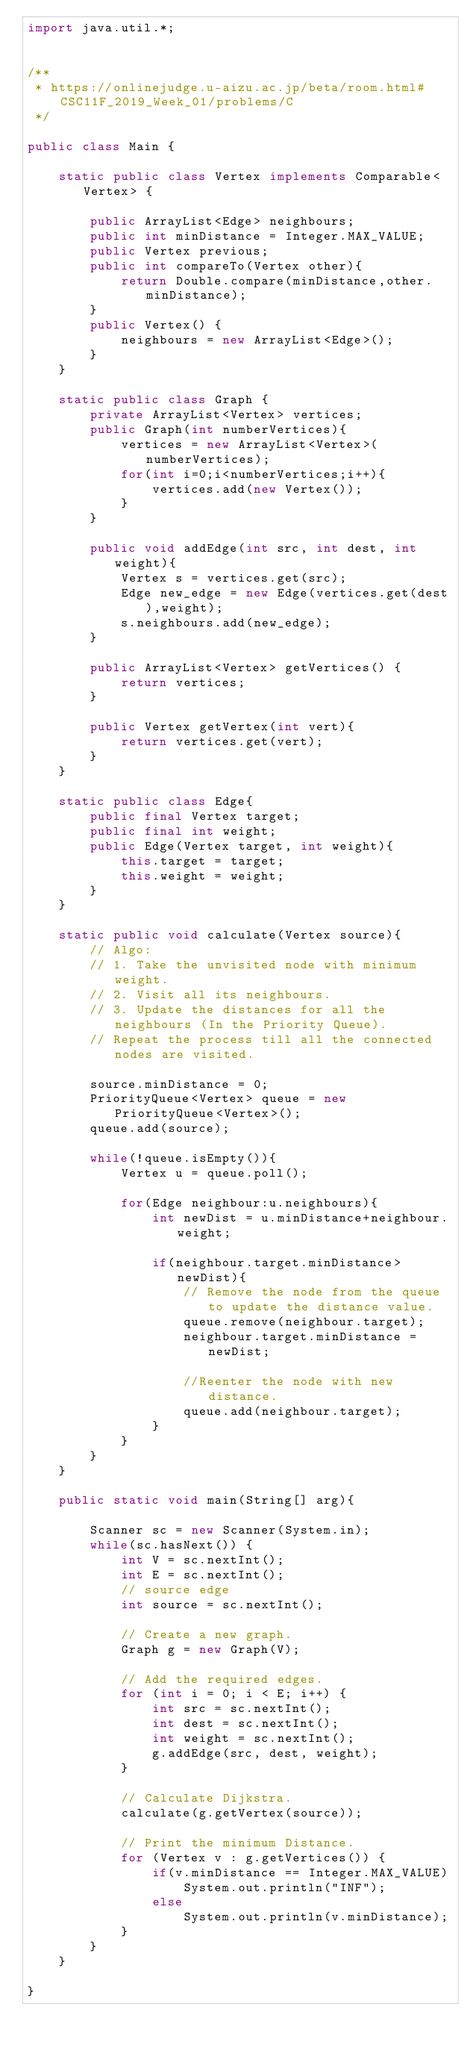<code> <loc_0><loc_0><loc_500><loc_500><_Java_>import java.util.*;


/**
 * https://onlinejudge.u-aizu.ac.jp/beta/room.html#CSC11F_2019_Week_01/problems/C
 */

public class Main {

    static public class Vertex implements Comparable<Vertex> {
    
        public ArrayList<Edge> neighbours;
        public int minDistance = Integer.MAX_VALUE;
        public Vertex previous;
        public int compareTo(Vertex other){
            return Double.compare(minDistance,other.minDistance);
        }
        public Vertex() {
            neighbours = new ArrayList<Edge>();
        }
    }
    
    static public class Graph {
        private ArrayList<Vertex> vertices;
        public Graph(int numberVertices){
            vertices = new ArrayList<Vertex>(numberVertices);
            for(int i=0;i<numberVertices;i++){
                vertices.add(new Vertex());
            }
        }
    
        public void addEdge(int src, int dest, int weight){
            Vertex s = vertices.get(src);
            Edge new_edge = new Edge(vertices.get(dest),weight);
            s.neighbours.add(new_edge);
        }
    
        public ArrayList<Vertex> getVertices() {
            return vertices;
        }
    
        public Vertex getVertex(int vert){
            return vertices.get(vert);
        }
    }
    
    static public class Edge{
        public final Vertex target;
        public final int weight;
        public Edge(Vertex target, int weight){
            this.target = target;
            this.weight = weight;
        }
    }

    static public void calculate(Vertex source){
        // Algo:
        // 1. Take the unvisited node with minimum weight.
        // 2. Visit all its neighbours.
        // 3. Update the distances for all the neighbours (In the Priority Queue).
        // Repeat the process till all the connected nodes are visited.

        source.minDistance = 0;
        PriorityQueue<Vertex> queue = new PriorityQueue<Vertex>();
        queue.add(source);

        while(!queue.isEmpty()){
            Vertex u = queue.poll();

            for(Edge neighbour:u.neighbours){
                int newDist = u.minDistance+neighbour.weight;

                if(neighbour.target.minDistance>newDist){
                    // Remove the node from the queue to update the distance value.
                    queue.remove(neighbour.target);
                    neighbour.target.minDistance = newDist;

                    //Reenter the node with new distance.
                    queue.add(neighbour.target);
                }
            }
        }
    }

    public static void main(String[] arg){

        Scanner sc = new Scanner(System.in);
        while(sc.hasNext()) {
            int V = sc.nextInt();
            int E = sc.nextInt();
            // source edge
            int source = sc.nextInt();

            // Create a new graph.
            Graph g = new Graph(V);

            // Add the required edges.
            for (int i = 0; i < E; i++) {
                int src = sc.nextInt();
                int dest = sc.nextInt();
                int weight = sc.nextInt();
                g.addEdge(src, dest, weight);
            }

            // Calculate Dijkstra.
            calculate(g.getVertex(source));

            // Print the minimum Distance.
            for (Vertex v : g.getVertices()) {
                if(v.minDistance == Integer.MAX_VALUE)
                    System.out.println("INF");
                else
                    System.out.println(v.minDistance);
            }
        }
    }

}

</code> 